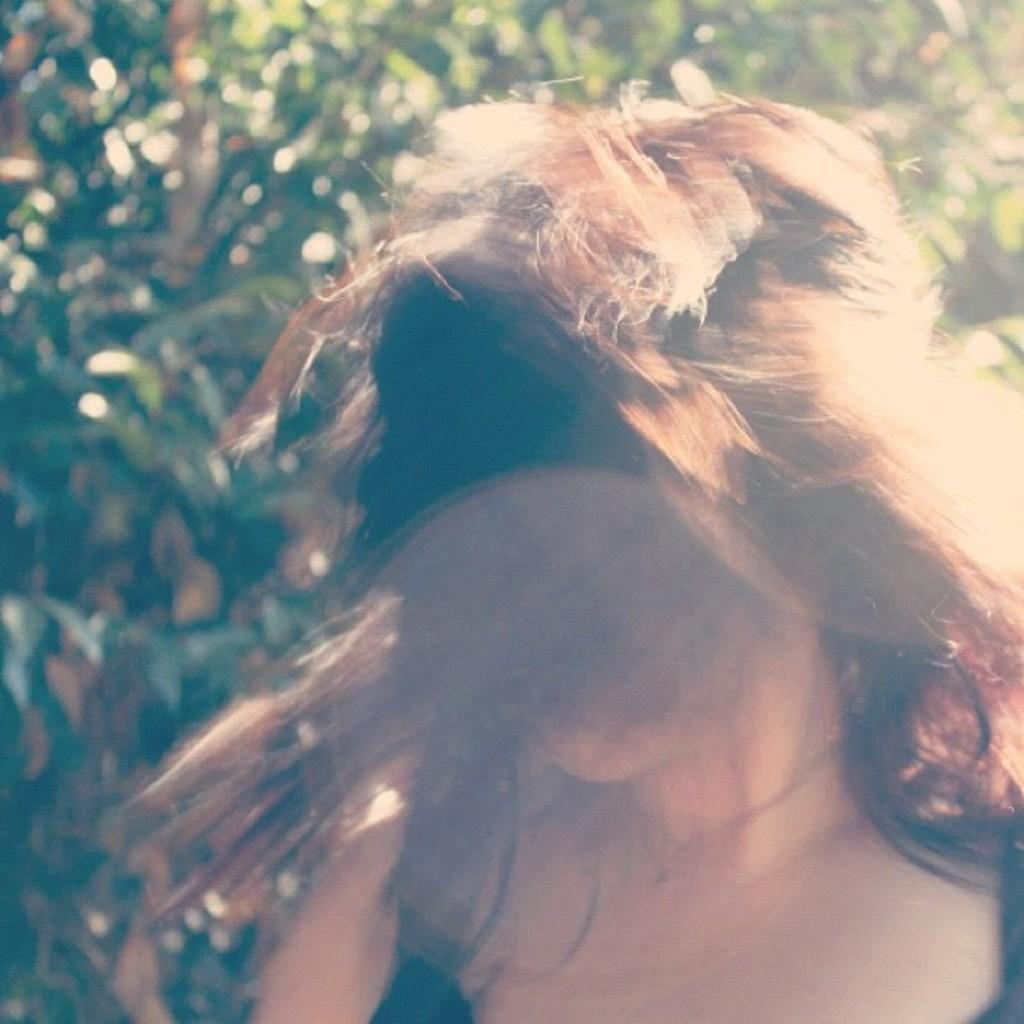Who is the main subject in the image? There is a girl in the image. Can you describe the girl's position in the image? The girl is standing in the front. What can be seen in the background of the image? There are trees behind the girl. Can you see a tiger in the image? No, there is no tiger present in the image. 